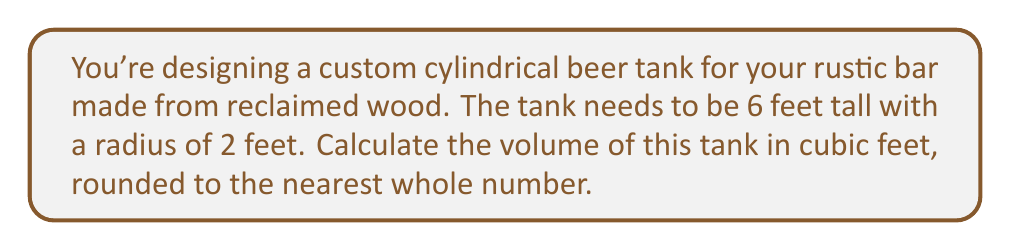Give your solution to this math problem. To solve this problem, we'll use the formula for the volume of a cylinder:

$$V = \pi r^2 h$$

Where:
$V$ = volume
$r$ = radius
$h$ = height

Given:
$r = 2$ feet
$h = 6$ feet

Let's substitute these values into our formula:

$$V = \pi (2 \text{ ft})^2 (6 \text{ ft})$$

Simplify:
$$V = \pi (4 \text{ ft}^2) (6 \text{ ft})$$
$$V = 24\pi \text{ ft}^3$$

Now, let's calculate this value:
$$V \approx 24 * 3.14159 \text{ ft}^3$$
$$V \approx 75.39816 \text{ ft}^3$$

Rounding to the nearest whole number:
$$V \approx 75 \text{ ft}^3$$
Answer: 75 cubic feet 